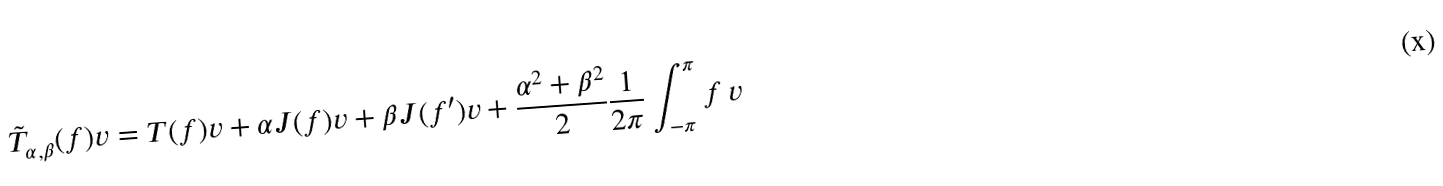Convert formula to latex. <formula><loc_0><loc_0><loc_500><loc_500>\tilde { T } _ { \alpha , \beta } ( f ) v = T ( f ) v + \alpha J ( f ) v + \beta J ( f ^ { \prime } ) v + \frac { \alpha ^ { 2 } + \beta ^ { 2 } } { 2 } \frac { 1 } { 2 \pi } \int _ { - \pi } ^ { \pi } f \, v</formula> 